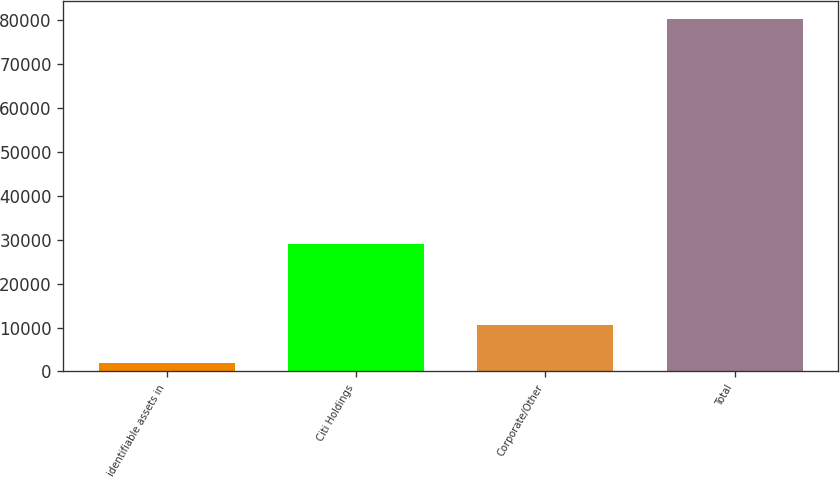<chart> <loc_0><loc_0><loc_500><loc_500><bar_chart><fcel>identifiable assets in<fcel>Citi Holdings<fcel>Corporate/Other<fcel>Total<nl><fcel>2009<fcel>29128<fcel>10555<fcel>80285<nl></chart> 